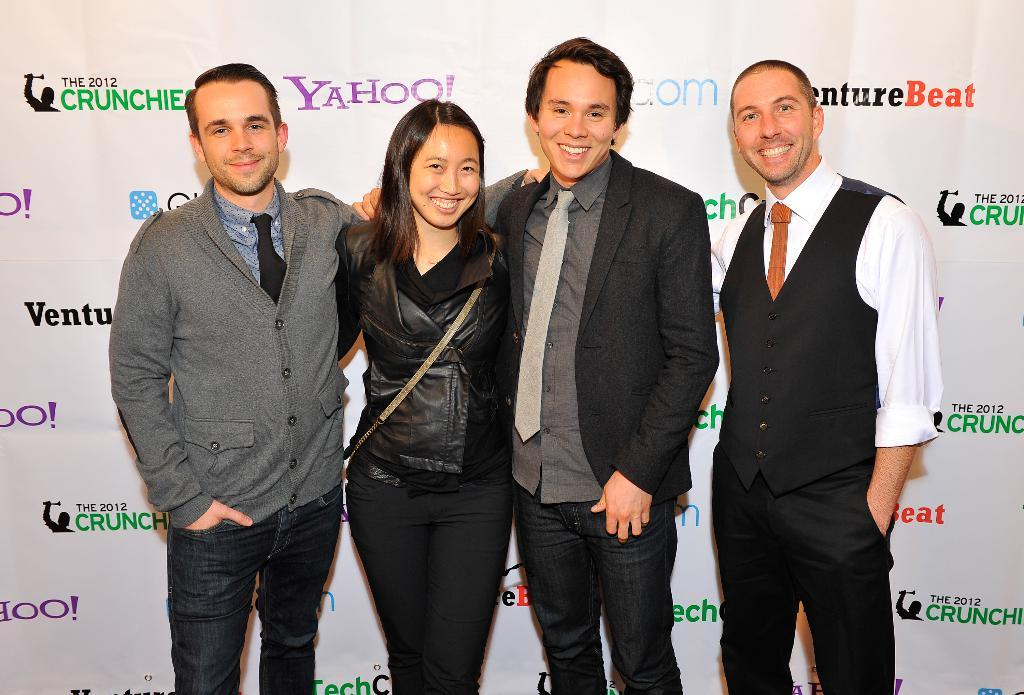Who is present in the image? There are people in the image. What are the people doing in the image? The people are smiling and posing for the camera. Is there any additional information about the image? Yes, there is a sponsor banner in the image. Is it raining in the image? There is no indication of rain in the image. What memory is being captured in the image? The image does not provide information about the specific memory being captured; it only shows people smiling and posing for the camera. 